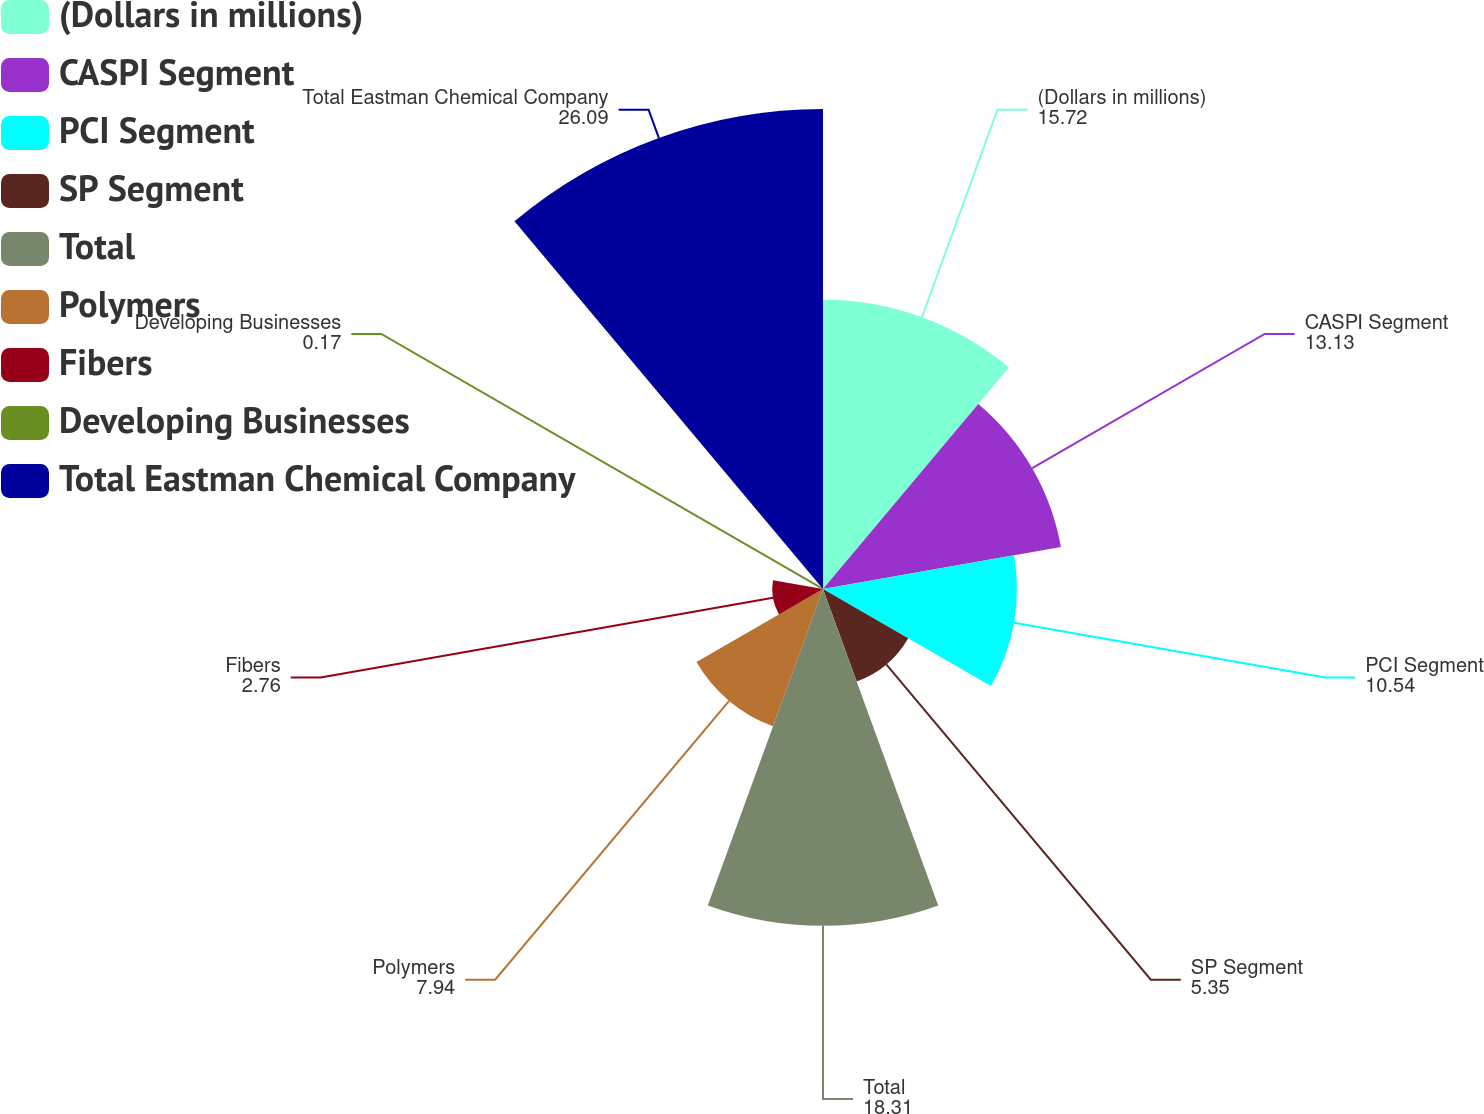<chart> <loc_0><loc_0><loc_500><loc_500><pie_chart><fcel>(Dollars in millions)<fcel>CASPI Segment<fcel>PCI Segment<fcel>SP Segment<fcel>Total<fcel>Polymers<fcel>Fibers<fcel>Developing Businesses<fcel>Total Eastman Chemical Company<nl><fcel>15.72%<fcel>13.13%<fcel>10.54%<fcel>5.35%<fcel>18.31%<fcel>7.94%<fcel>2.76%<fcel>0.17%<fcel>26.09%<nl></chart> 